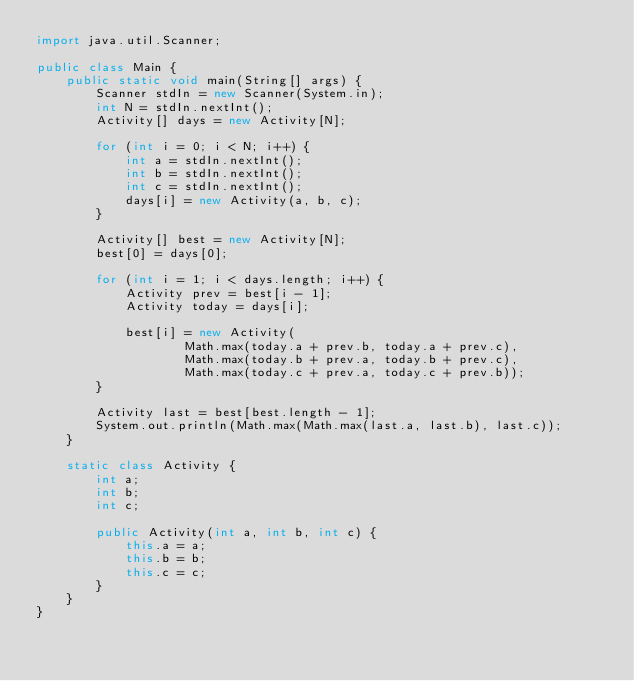Convert code to text. <code><loc_0><loc_0><loc_500><loc_500><_Java_>import java.util.Scanner;

public class Main {
    public static void main(String[] args) {
        Scanner stdIn = new Scanner(System.in);
        int N = stdIn.nextInt();
        Activity[] days = new Activity[N];

        for (int i = 0; i < N; i++) {
            int a = stdIn.nextInt();
            int b = stdIn.nextInt();
            int c = stdIn.nextInt();
            days[i] = new Activity(a, b, c);
        }
        
        Activity[] best = new Activity[N];
        best[0] = days[0];

        for (int i = 1; i < days.length; i++) {
            Activity prev = best[i - 1];
            Activity today = days[i];

            best[i] = new Activity(
                    Math.max(today.a + prev.b, today.a + prev.c),
                    Math.max(today.b + prev.a, today.b + prev.c),
                    Math.max(today.c + prev.a, today.c + prev.b));
        }

        Activity last = best[best.length - 1];
        System.out.println(Math.max(Math.max(last.a, last.b), last.c));
    }

    static class Activity {
        int a;
        int b;
        int c;

        public Activity(int a, int b, int c) {
            this.a = a;
            this.b = b;
            this.c = c;
        }
    }
}
</code> 